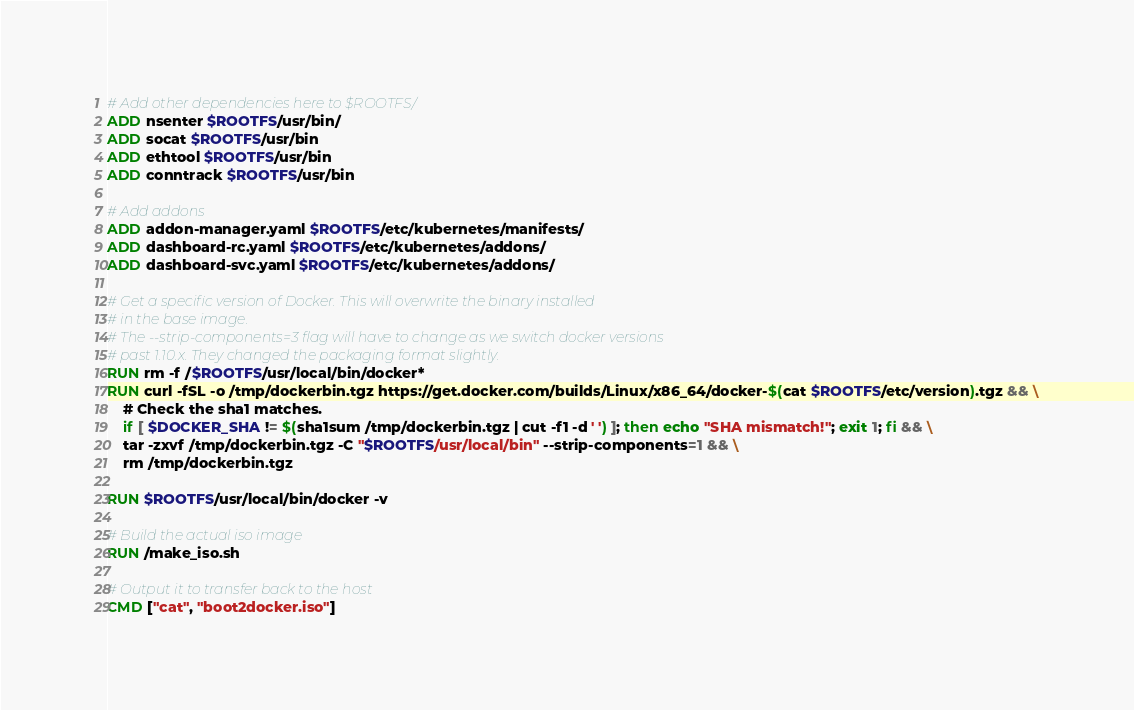Convert code to text. <code><loc_0><loc_0><loc_500><loc_500><_Dockerfile_>
# Add other dependencies here to $ROOTFS/
ADD nsenter $ROOTFS/usr/bin/
ADD socat $ROOTFS/usr/bin
ADD ethtool $ROOTFS/usr/bin
ADD conntrack $ROOTFS/usr/bin

# Add addons
ADD addon-manager.yaml $ROOTFS/etc/kubernetes/manifests/
ADD dashboard-rc.yaml $ROOTFS/etc/kubernetes/addons/
ADD dashboard-svc.yaml $ROOTFS/etc/kubernetes/addons/

# Get a specific version of Docker. This will overwrite the binary installed
# in the base image.
# The --strip-components=3 flag will have to change as we switch docker versions
# past 1.10.x. They changed the packaging format slightly.
RUN rm -f /$ROOTFS/usr/local/bin/docker*
RUN curl -fSL -o /tmp/dockerbin.tgz https://get.docker.com/builds/Linux/x86_64/docker-$(cat $ROOTFS/etc/version).tgz && \
	# Check the sha1 matches.
	if [ $DOCKER_SHA != $(sha1sum /tmp/dockerbin.tgz | cut -f1 -d ' ') ]; then echo "SHA mismatch!"; exit 1; fi && \
    tar -zxvf /tmp/dockerbin.tgz -C "$ROOTFS/usr/local/bin" --strip-components=1 && \
    rm /tmp/dockerbin.tgz

RUN $ROOTFS/usr/local/bin/docker -v

# Build the actual iso image
RUN /make_iso.sh

# Output it to transfer back to the host
CMD ["cat", "boot2docker.iso"]
</code> 